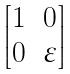<formula> <loc_0><loc_0><loc_500><loc_500>\begin{bmatrix} 1 & 0 \\ 0 & \varepsilon \end{bmatrix}</formula> 